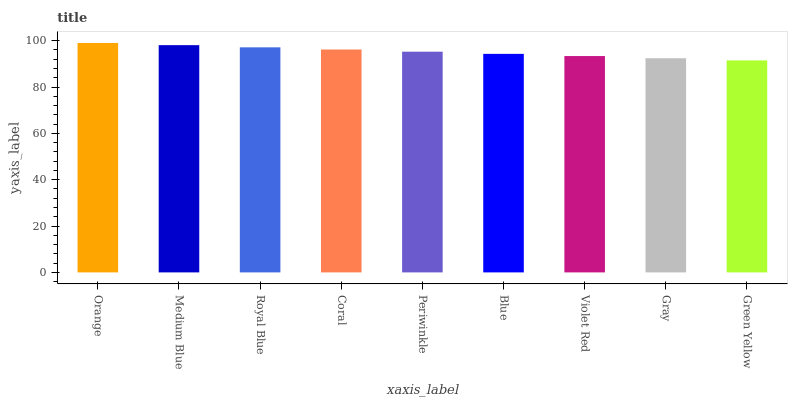Is Orange the maximum?
Answer yes or no. Yes. Is Medium Blue the minimum?
Answer yes or no. No. Is Medium Blue the maximum?
Answer yes or no. No. Is Orange greater than Medium Blue?
Answer yes or no. Yes. Is Medium Blue less than Orange?
Answer yes or no. Yes. Is Medium Blue greater than Orange?
Answer yes or no. No. Is Orange less than Medium Blue?
Answer yes or no. No. Is Periwinkle the high median?
Answer yes or no. Yes. Is Periwinkle the low median?
Answer yes or no. Yes. Is Gray the high median?
Answer yes or no. No. Is Violet Red the low median?
Answer yes or no. No. 